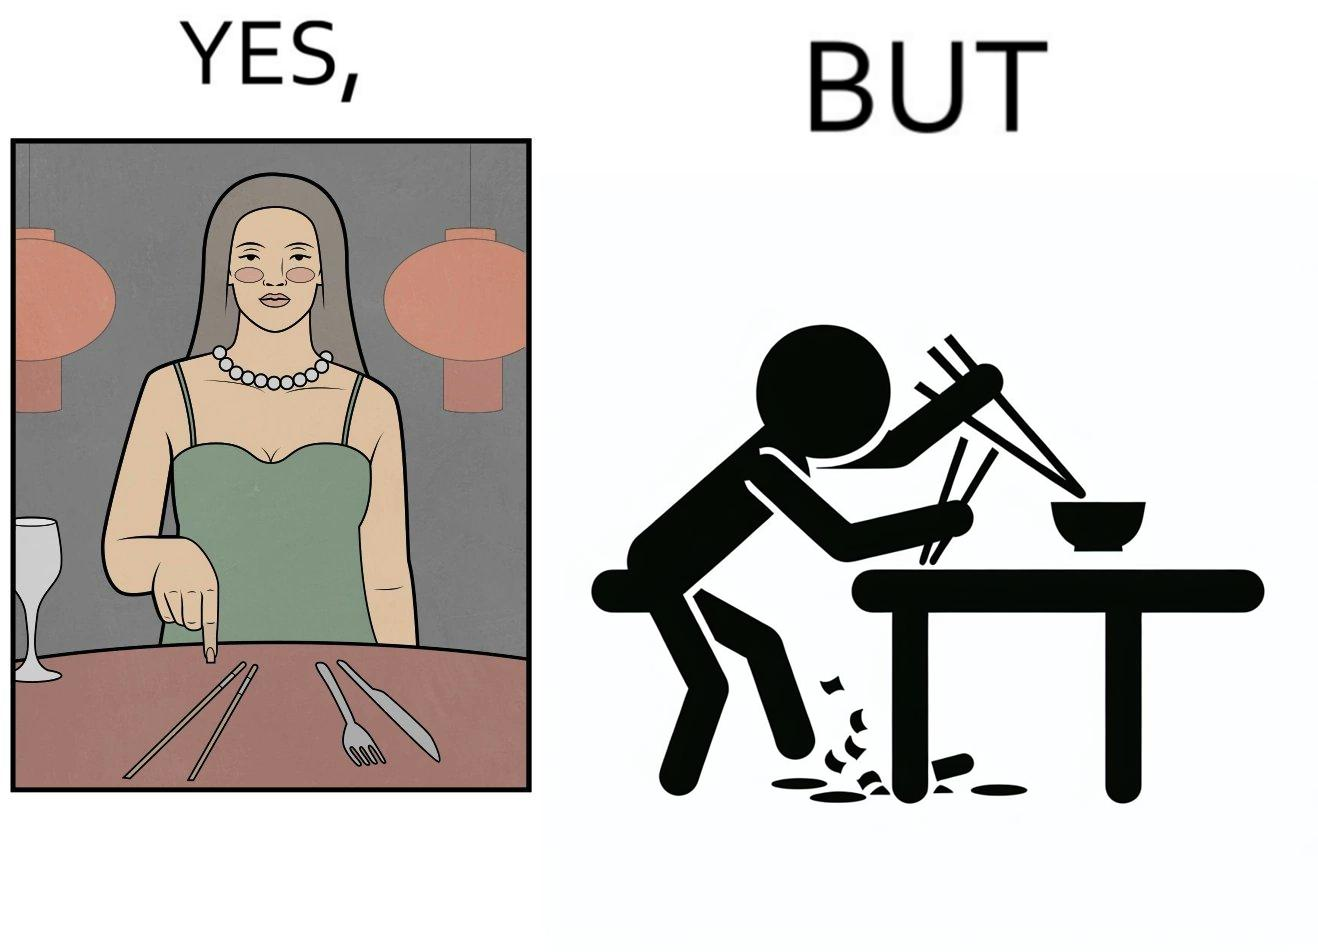Does this image contain satire or humor? Yes, this image is satirical. 